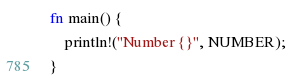Convert code to text. <code><loc_0><loc_0><loc_500><loc_500><_Rust_>fn main() {
    println!("Number {}", NUMBER);
}
</code> 